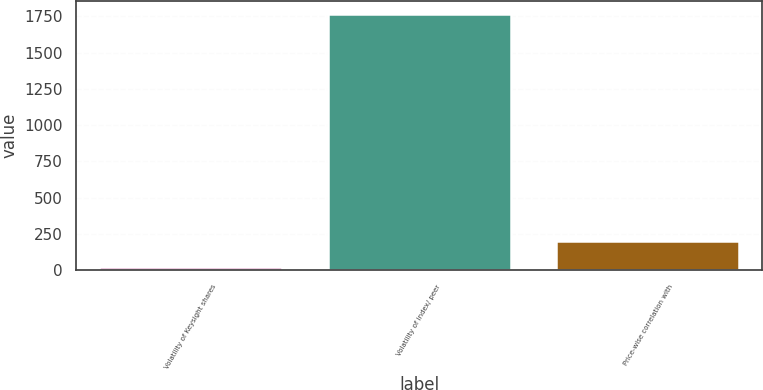<chart> <loc_0><loc_0><loc_500><loc_500><bar_chart><fcel>Volatility of Keysight shares<fcel>Volatility of index/ peer<fcel>Price-wise correlation with<nl><fcel>26<fcel>1767<fcel>200.1<nl></chart> 